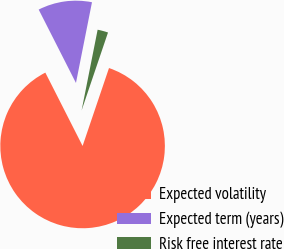<chart> <loc_0><loc_0><loc_500><loc_500><pie_chart><fcel>Expected volatility<fcel>Expected term (years)<fcel>Risk free interest rate<nl><fcel>87.32%<fcel>10.6%<fcel>2.08%<nl></chart> 